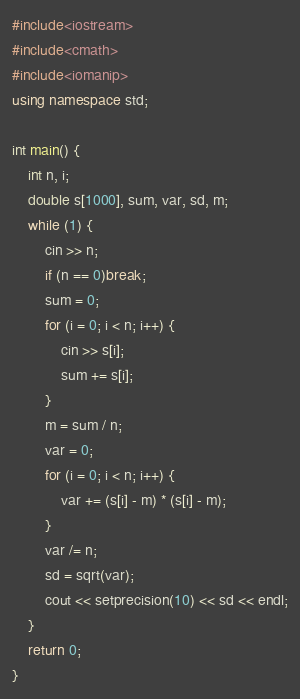Convert code to text. <code><loc_0><loc_0><loc_500><loc_500><_C++_>#include<iostream>
#include<cmath>
#include<iomanip>
using namespace std;

int main() {
	int n, i;
	double s[1000], sum, var, sd, m;
	while (1) {
		cin >> n;
		if (n == 0)break;
		sum = 0;
		for (i = 0; i < n; i++) {
			cin >> s[i];
			sum += s[i];
		}
		m = sum / n;
		var = 0;
		for (i = 0; i < n; i++) {
			var += (s[i] - m) * (s[i] - m);
		}
		var /= n;
		sd = sqrt(var);
		cout << setprecision(10) << sd << endl;
	}
	return 0;
}</code> 